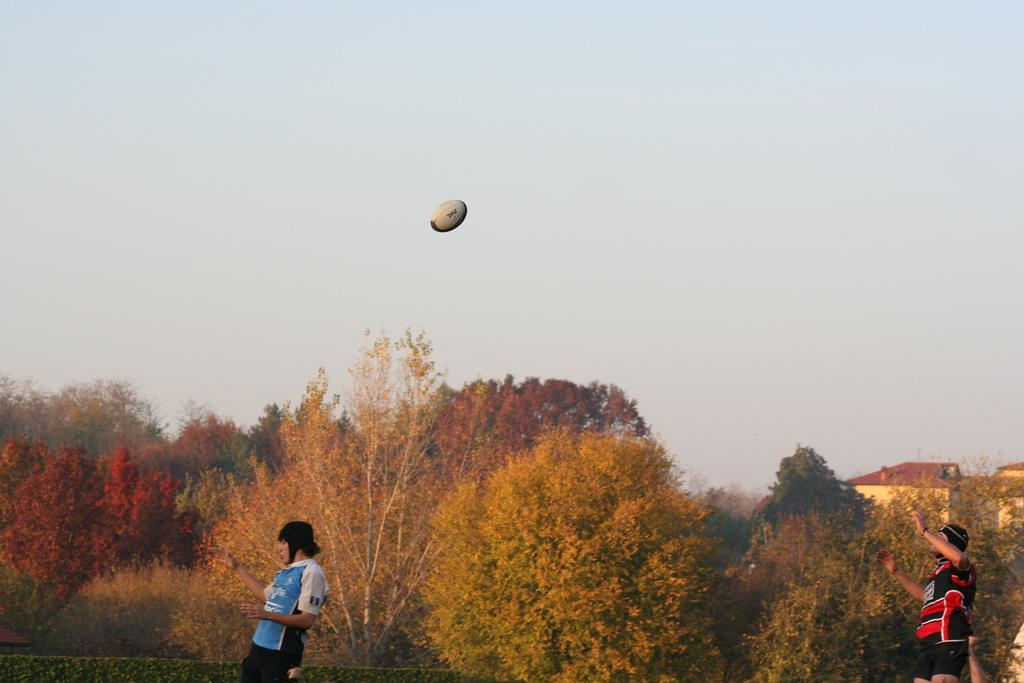How many people are in the image? There are two people in the image. What can be seen in the background of the image? Trees, houses, a ball, and the sky are visible in the background of the image. Where is the throne located in the image? There is no throne present in the image. How does the ball move in the image? The ball does not move in the image; it is stationary in the background. 